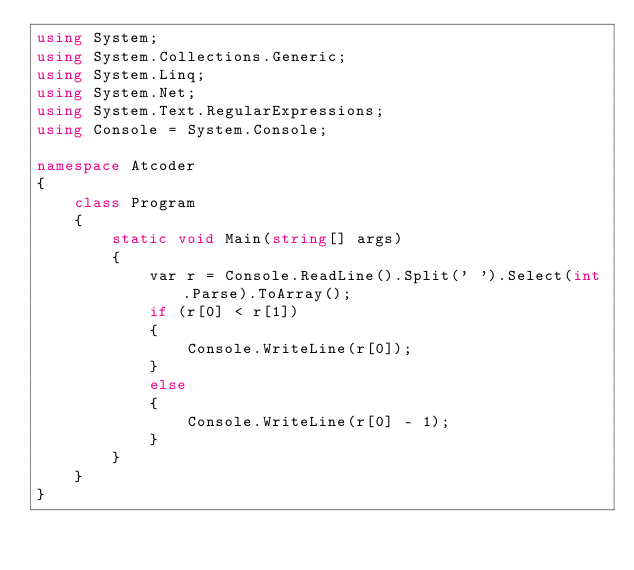<code> <loc_0><loc_0><loc_500><loc_500><_C#_>using System;
using System.Collections.Generic;
using System.Linq;
using System.Net;
using System.Text.RegularExpressions;
using Console = System.Console;

namespace Atcoder
{
    class Program
    {
        static void Main(string[] args)
        {
            var r = Console.ReadLine().Split(' ').Select(int.Parse).ToArray();
            if (r[0] < r[1])
            {
                Console.WriteLine(r[0]);
            }
            else
            {
                Console.WriteLine(r[0] - 1);
            }
        }
    }
}</code> 